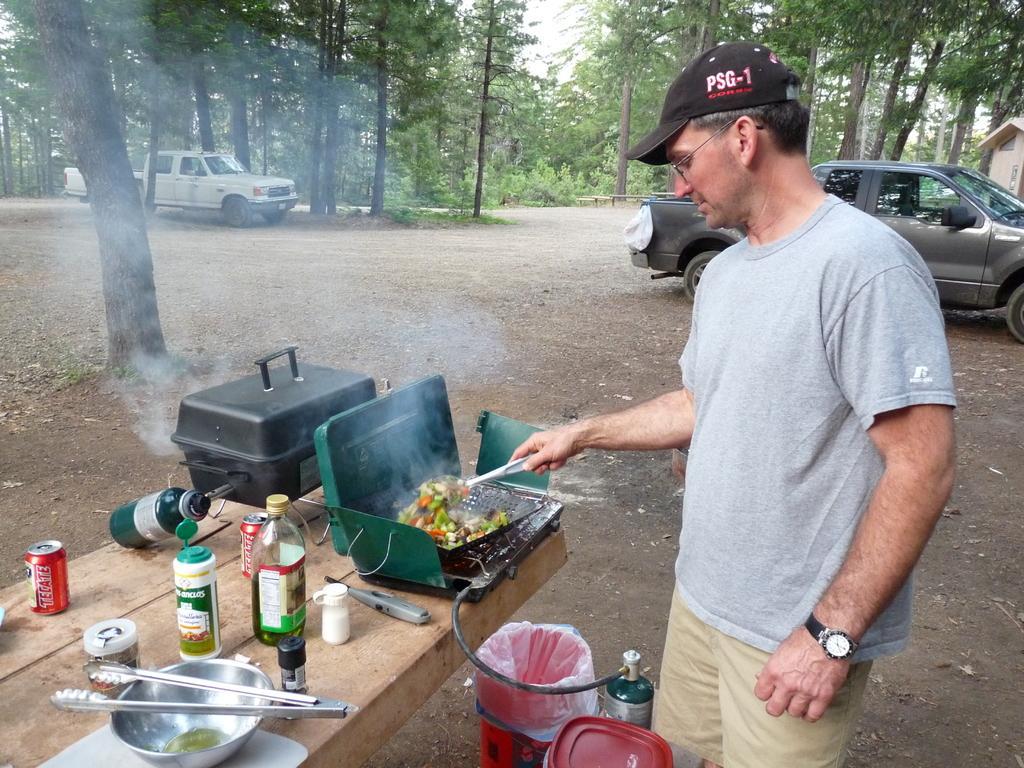Please provide a concise description of this image. In the foreground of this picture, there is a man standing and cooking food and there are bowl, platter, few bottles, tin and a bucket is placed on the table. There is a cylinder and bucket is placed on the ground. In the background, we can see car, truck, trees, house and the sky. 